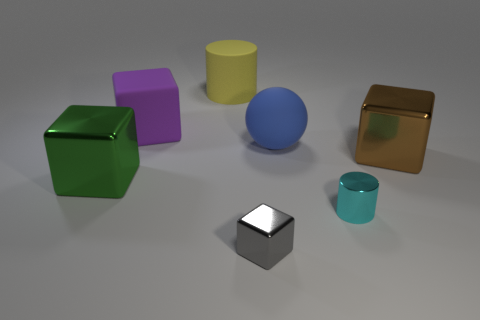How many things are either big metal things that are on the right side of the blue sphere or big cylinders?
Your answer should be very brief. 2. What color is the big rubber object that is the same shape as the large brown metal object?
Your answer should be very brief. Purple. Do the big purple thing and the big metallic object that is to the left of the gray metallic thing have the same shape?
Provide a short and direct response. Yes. How many things are either big matte objects to the right of the big purple thing or brown objects that are to the right of the green object?
Keep it short and to the point. 3. Is the number of matte spheres that are on the left side of the sphere less than the number of big yellow objects?
Give a very brief answer. Yes. Do the tiny cyan cylinder and the cylinder that is behind the large green shiny object have the same material?
Offer a terse response. No. What is the purple block made of?
Keep it short and to the point. Rubber. What is the material of the cylinder that is on the left side of the small metallic object behind the tiny object in front of the cyan thing?
Make the answer very short. Rubber. Is there anything else that is the same shape as the big blue thing?
Offer a terse response. No. The metal cube behind the object left of the purple block is what color?
Offer a terse response. Brown. 